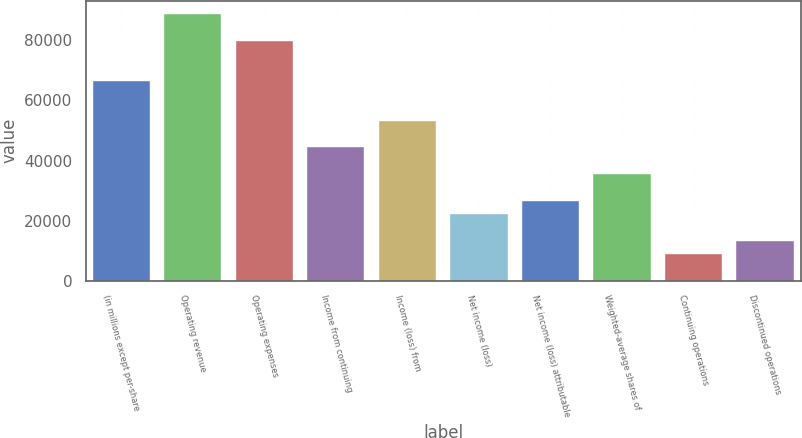Convert chart to OTSL. <chart><loc_0><loc_0><loc_500><loc_500><bar_chart><fcel>(in millions except per-share<fcel>Operating revenue<fcel>Operating expenses<fcel>Income from continuing<fcel>Income (loss) from<fcel>Net income (loss)<fcel>Net income (loss) attributable<fcel>Weighted-average shares of<fcel>Continuing operations<fcel>Discontinued operations<nl><fcel>66590.7<fcel>88787.4<fcel>79908.7<fcel>44394<fcel>53272.6<fcel>22197.3<fcel>26636.6<fcel>35515.3<fcel>8879.24<fcel>13318.6<nl></chart> 